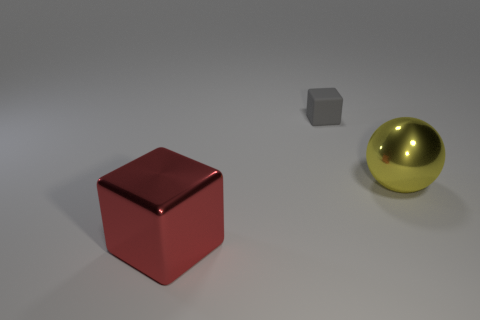Add 3 tiny rubber things. How many objects exist? 6 Subtract all spheres. How many objects are left? 2 Subtract all red blocks. Subtract all cyan balls. How many blocks are left? 1 Subtract all big green rubber balls. Subtract all gray rubber cubes. How many objects are left? 2 Add 1 big spheres. How many big spheres are left? 2 Add 1 large red shiny objects. How many large red shiny objects exist? 2 Subtract 0 brown cylinders. How many objects are left? 3 